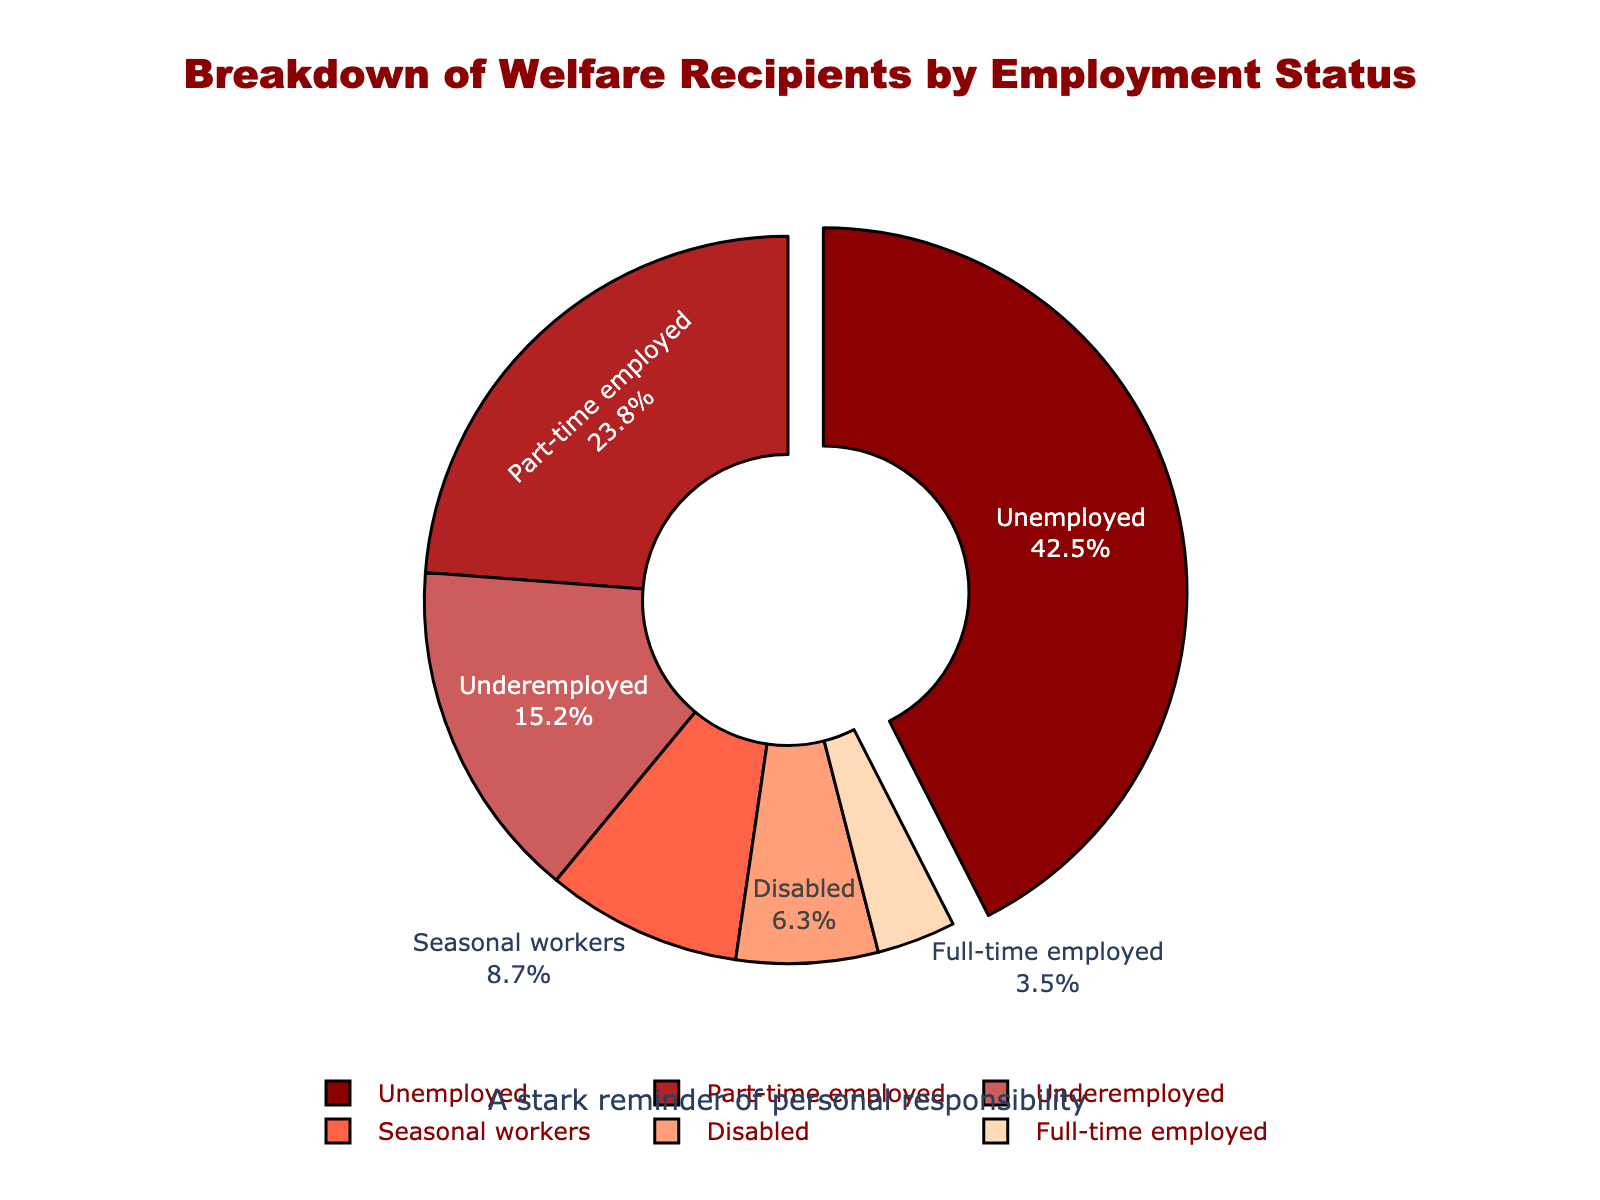What proportion of welfare recipients are either unemployed or part-time employed? To find the proportion of welfare recipients who are either unemployed or part-time employed, we combine the percentages for these two groups: 42.5% (unemployed) + 23.8% (part-time employed). This equals 66.3%.
Answer: 66.3% Which group of welfare recipients is the largest, and by what margin does it exceed the next largest group? The largest group of welfare recipients is the unemployed at 42.5%. The next largest group is part-time employed at 23.8%. To find the margin, subtract 23.8% from 42.5%: 42.5% - 23.8% = 18.7%.
Answer: Unemployed; 18.7% What is the combined percentage of underemployed, seasonal workers, and disabled welfare recipients? To find the combined percentage, add the values for underemployed (15.2%), seasonal workers (8.7%), and disabled (6.3%): 15.2% + 8.7% + 6.3% = 30.2%.
Answer: 30.2% Which employment status category has the smallest percentage of welfare recipients? By observing the pie chart, the employment status category with the smallest percentage of welfare recipients is full-time employed at 3.5%.
Answer: Full-time employed How much larger is the proportion of unemployed welfare recipients compared to underemployed welfare recipients? To determine how much larger the proportion is, subtract the percentage of underemployed (15.2%) from the percentage of unemployed (42.5%): 42.5% - 15.2% = 27.3%.
Answer: 27.3% What percentage of welfare recipients are employed (including both part-time and full-time)? To find the percentage of welfare recipients who are employed, combine the percentages of part-time (23.8%) and full-time (3.5%) employed individuals: 23.8% + 3.5% = 27.3%.
Answer: 27.3% What is the total percentage of welfare recipients who are not fully employed (excluding full-time employment)? To find this, add the percentages of unemployed (42.5%), part-time employed (23.8%), underemployed (15.2%), seasonal workers (8.7%), and disabled (6.3%): 42.5% + 23.8% + 15.2% + 8.7% + 6.3% = 96.5%.
Answer: 96.5% Which employment status category is highlighted or pulled out in the pie chart, and why might that be the case? Observing the visual attributes of the pie chart, the unemployed category is visually highlighted or pulled out. This may be to emphasize the significant proportion of welfare recipients who are unemployed.
Answer: Unemployed 